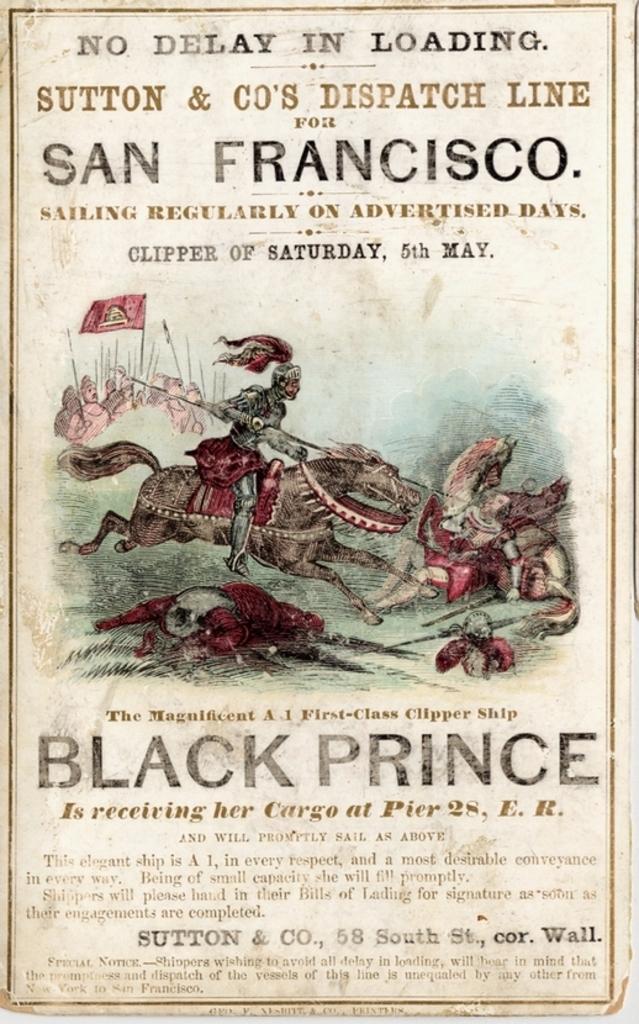What date is shown?
Make the answer very short. May 5th. What city is on this?
Keep it short and to the point. San francisco. 